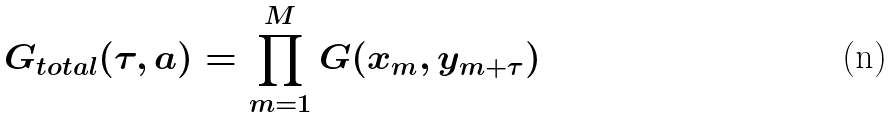Convert formula to latex. <formula><loc_0><loc_0><loc_500><loc_500>G _ { t o t a l } ( \tau , a ) = \prod _ { m = 1 } ^ { M } G ( x _ { m } , y _ { m + \tau } )</formula> 